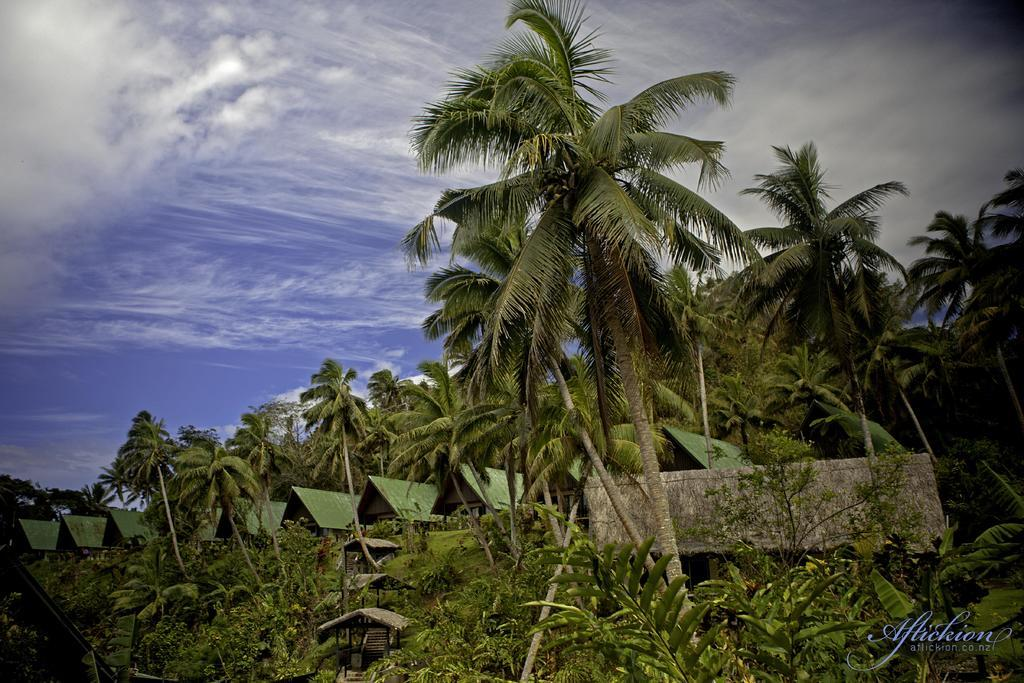What type of vegetation can be seen in the image? There are trees and plants in the image. What type of structures are present in the image? There are sheds in the image. Is there any text visible in the image? Yes, there is some text in the image. What can be seen in the sky at the top of the image? There are clouds in the sky at the top of the image. What type of knot is being used to secure the trees in the image? There is no knot visible in the image, as it features trees, sheds, plants, text, and clouds in the sky. What type of competition is taking place in the image? There is no competition present in the image; it is a scene with trees, sheds, plants, text, and clouds in the sky. 